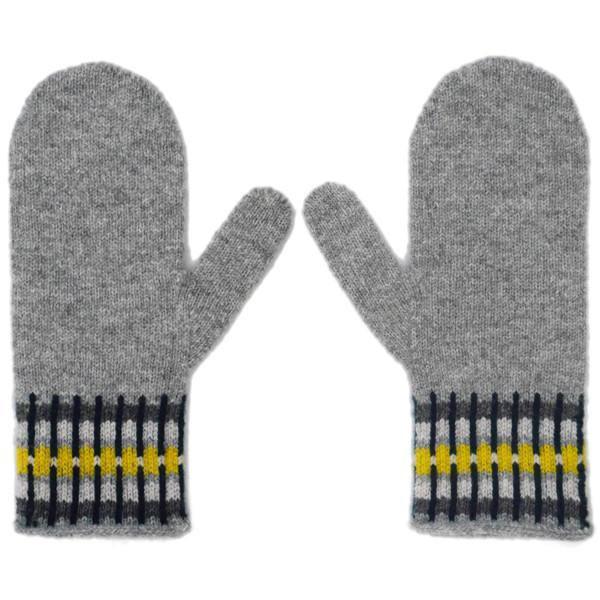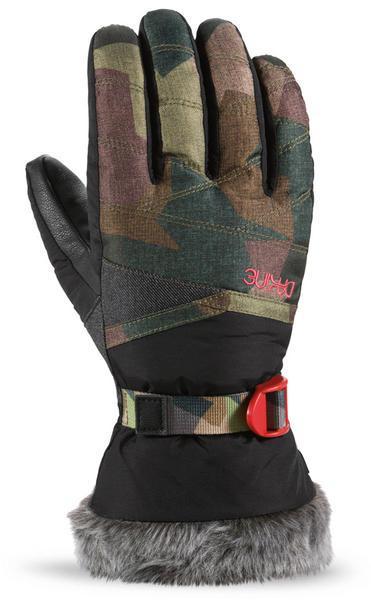The first image is the image on the left, the second image is the image on the right. Considering the images on both sides, is "One image shows a matched pair of mittens, and the other image includes a glove with fingers." valid? Answer yes or no. Yes. The first image is the image on the left, the second image is the image on the right. Analyze the images presented: Is the assertion "A glove with individual fingers is visible." valid? Answer yes or no. Yes. 